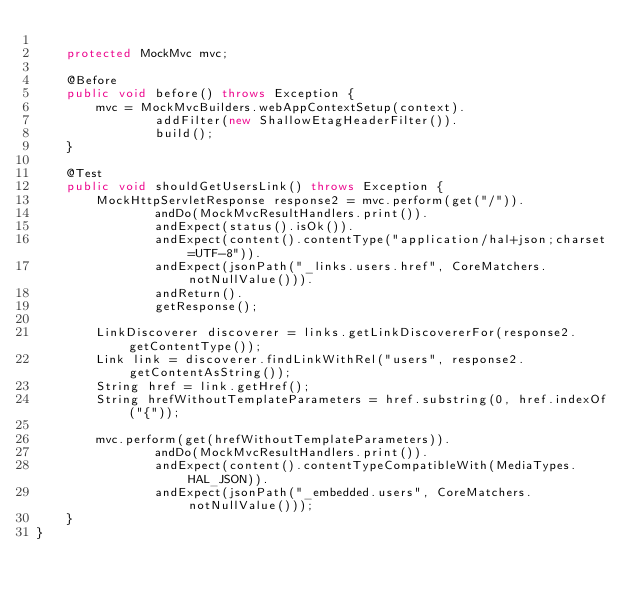<code> <loc_0><loc_0><loc_500><loc_500><_Java_>
    protected MockMvc mvc;

    @Before
    public void before() throws Exception {
        mvc = MockMvcBuilders.webAppContextSetup(context).
                addFilter(new ShallowEtagHeaderFilter()).
                build();
    }

    @Test
    public void shouldGetUsersLink() throws Exception {
        MockHttpServletResponse response2 = mvc.perform(get("/")).
                andDo(MockMvcResultHandlers.print()).
                andExpect(status().isOk()).
                andExpect(content().contentType("application/hal+json;charset=UTF-8")).
                andExpect(jsonPath("_links.users.href", CoreMatchers.notNullValue())).
                andReturn().
                getResponse();

        LinkDiscoverer discoverer = links.getLinkDiscovererFor(response2.getContentType());
        Link link = discoverer.findLinkWithRel("users", response2.getContentAsString());
        String href = link.getHref();
        String hrefWithoutTemplateParameters = href.substring(0, href.indexOf("{"));

        mvc.perform(get(hrefWithoutTemplateParameters)).
                andDo(MockMvcResultHandlers.print()).
                andExpect(content().contentTypeCompatibleWith(MediaTypes.HAL_JSON)).
                andExpect(jsonPath("_embedded.users", CoreMatchers.notNullValue()));
    }
}
</code> 